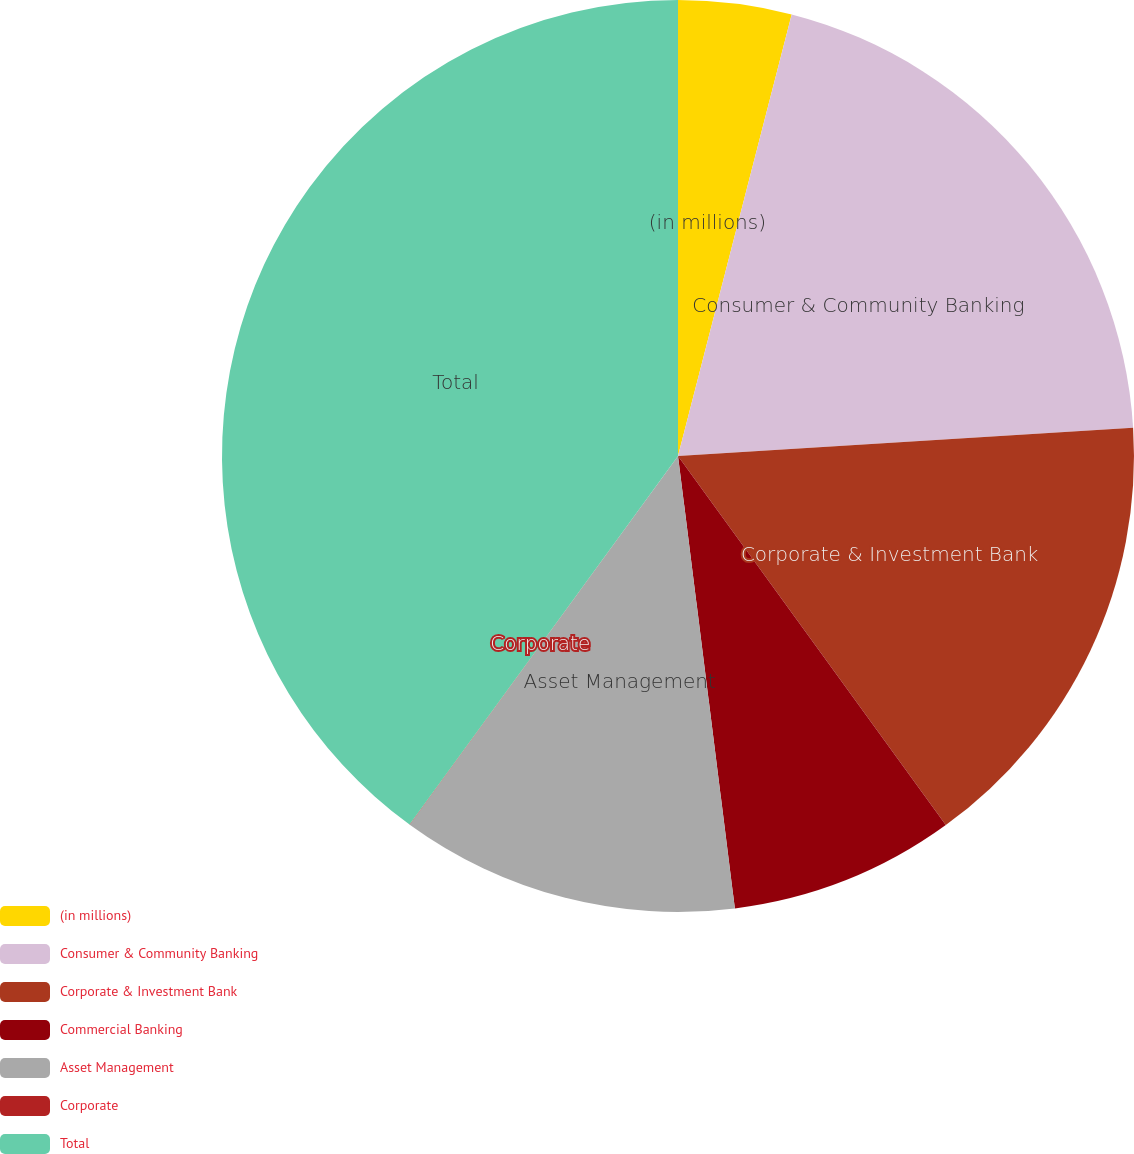<chart> <loc_0><loc_0><loc_500><loc_500><pie_chart><fcel>(in millions)<fcel>Consumer & Community Banking<fcel>Corporate & Investment Bank<fcel>Commercial Banking<fcel>Asset Management<fcel>Corporate<fcel>Total<nl><fcel>4.01%<fcel>20.0%<fcel>16.0%<fcel>8.0%<fcel>12.0%<fcel>0.01%<fcel>39.98%<nl></chart> 